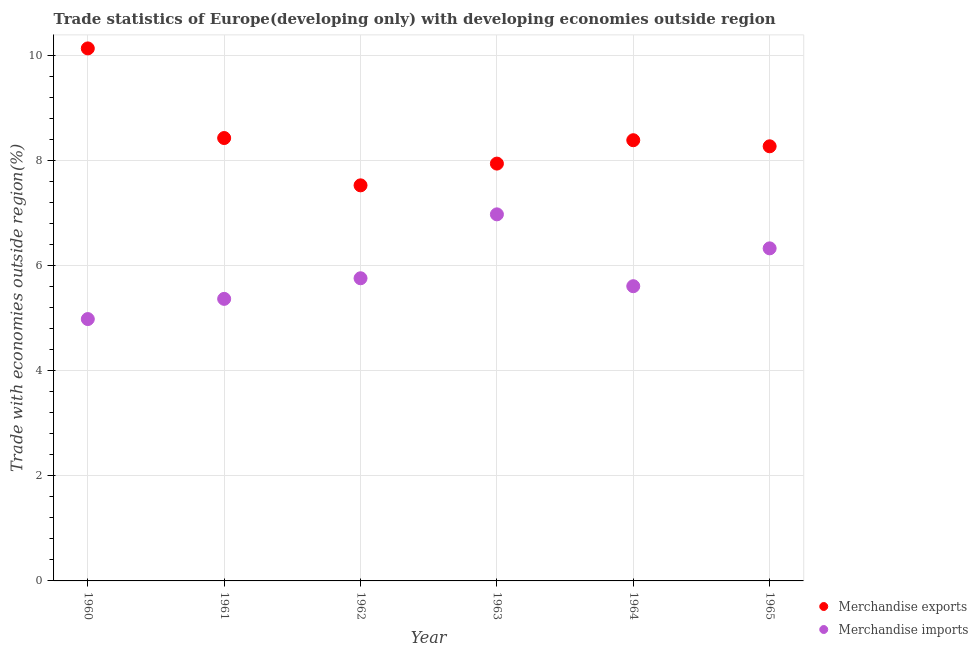What is the merchandise exports in 1960?
Ensure brevity in your answer.  10.13. Across all years, what is the maximum merchandise imports?
Give a very brief answer. 6.97. Across all years, what is the minimum merchandise imports?
Ensure brevity in your answer.  4.98. In which year was the merchandise imports maximum?
Your response must be concise. 1963. What is the total merchandise imports in the graph?
Your response must be concise. 35. What is the difference between the merchandise exports in 1963 and that in 1965?
Provide a short and direct response. -0.33. What is the difference between the merchandise imports in 1965 and the merchandise exports in 1964?
Keep it short and to the point. -2.06. What is the average merchandise exports per year?
Your answer should be compact. 8.44. In the year 1960, what is the difference between the merchandise imports and merchandise exports?
Keep it short and to the point. -5.15. In how many years, is the merchandise exports greater than 2.4 %?
Your answer should be very brief. 6. What is the ratio of the merchandise imports in 1961 to that in 1965?
Your answer should be compact. 0.85. What is the difference between the highest and the second highest merchandise imports?
Offer a terse response. 0.65. What is the difference between the highest and the lowest merchandise imports?
Provide a succinct answer. 1.99. In how many years, is the merchandise exports greater than the average merchandise exports taken over all years?
Offer a very short reply. 1. Does the merchandise imports monotonically increase over the years?
Your response must be concise. No. What is the difference between two consecutive major ticks on the Y-axis?
Ensure brevity in your answer.  2. Where does the legend appear in the graph?
Offer a terse response. Bottom right. How many legend labels are there?
Your answer should be compact. 2. What is the title of the graph?
Provide a succinct answer. Trade statistics of Europe(developing only) with developing economies outside region. Does "Urban" appear as one of the legend labels in the graph?
Give a very brief answer. No. What is the label or title of the Y-axis?
Provide a short and direct response. Trade with economies outside region(%). What is the Trade with economies outside region(%) of Merchandise exports in 1960?
Your answer should be compact. 10.13. What is the Trade with economies outside region(%) of Merchandise imports in 1960?
Your answer should be compact. 4.98. What is the Trade with economies outside region(%) in Merchandise exports in 1961?
Your response must be concise. 8.42. What is the Trade with economies outside region(%) in Merchandise imports in 1961?
Provide a short and direct response. 5.36. What is the Trade with economies outside region(%) of Merchandise exports in 1962?
Provide a succinct answer. 7.52. What is the Trade with economies outside region(%) in Merchandise imports in 1962?
Give a very brief answer. 5.76. What is the Trade with economies outside region(%) of Merchandise exports in 1963?
Your answer should be very brief. 7.94. What is the Trade with economies outside region(%) in Merchandise imports in 1963?
Provide a short and direct response. 6.97. What is the Trade with economies outside region(%) of Merchandise exports in 1964?
Keep it short and to the point. 8.38. What is the Trade with economies outside region(%) in Merchandise imports in 1964?
Offer a very short reply. 5.6. What is the Trade with economies outside region(%) of Merchandise exports in 1965?
Keep it short and to the point. 8.27. What is the Trade with economies outside region(%) of Merchandise imports in 1965?
Provide a short and direct response. 6.32. Across all years, what is the maximum Trade with economies outside region(%) of Merchandise exports?
Ensure brevity in your answer.  10.13. Across all years, what is the maximum Trade with economies outside region(%) of Merchandise imports?
Make the answer very short. 6.97. Across all years, what is the minimum Trade with economies outside region(%) of Merchandise exports?
Offer a very short reply. 7.52. Across all years, what is the minimum Trade with economies outside region(%) in Merchandise imports?
Your response must be concise. 4.98. What is the total Trade with economies outside region(%) in Merchandise exports in the graph?
Ensure brevity in your answer.  50.66. What is the total Trade with economies outside region(%) in Merchandise imports in the graph?
Give a very brief answer. 35. What is the difference between the Trade with economies outside region(%) of Merchandise exports in 1960 and that in 1961?
Keep it short and to the point. 1.7. What is the difference between the Trade with economies outside region(%) of Merchandise imports in 1960 and that in 1961?
Offer a very short reply. -0.38. What is the difference between the Trade with economies outside region(%) in Merchandise exports in 1960 and that in 1962?
Make the answer very short. 2.6. What is the difference between the Trade with economies outside region(%) of Merchandise imports in 1960 and that in 1962?
Your answer should be compact. -0.78. What is the difference between the Trade with economies outside region(%) in Merchandise exports in 1960 and that in 1963?
Your response must be concise. 2.19. What is the difference between the Trade with economies outside region(%) in Merchandise imports in 1960 and that in 1963?
Give a very brief answer. -1.99. What is the difference between the Trade with economies outside region(%) of Merchandise exports in 1960 and that in 1964?
Give a very brief answer. 1.75. What is the difference between the Trade with economies outside region(%) in Merchandise imports in 1960 and that in 1964?
Provide a succinct answer. -0.63. What is the difference between the Trade with economies outside region(%) in Merchandise exports in 1960 and that in 1965?
Ensure brevity in your answer.  1.86. What is the difference between the Trade with economies outside region(%) of Merchandise imports in 1960 and that in 1965?
Ensure brevity in your answer.  -1.34. What is the difference between the Trade with economies outside region(%) in Merchandise exports in 1961 and that in 1962?
Offer a terse response. 0.9. What is the difference between the Trade with economies outside region(%) of Merchandise imports in 1961 and that in 1962?
Offer a terse response. -0.39. What is the difference between the Trade with economies outside region(%) in Merchandise exports in 1961 and that in 1963?
Give a very brief answer. 0.49. What is the difference between the Trade with economies outside region(%) in Merchandise imports in 1961 and that in 1963?
Your response must be concise. -1.61. What is the difference between the Trade with economies outside region(%) in Merchandise exports in 1961 and that in 1964?
Your answer should be very brief. 0.04. What is the difference between the Trade with economies outside region(%) in Merchandise imports in 1961 and that in 1964?
Give a very brief answer. -0.24. What is the difference between the Trade with economies outside region(%) of Merchandise exports in 1961 and that in 1965?
Provide a short and direct response. 0.16. What is the difference between the Trade with economies outside region(%) in Merchandise imports in 1961 and that in 1965?
Make the answer very short. -0.96. What is the difference between the Trade with economies outside region(%) in Merchandise exports in 1962 and that in 1963?
Keep it short and to the point. -0.41. What is the difference between the Trade with economies outside region(%) of Merchandise imports in 1962 and that in 1963?
Offer a very short reply. -1.22. What is the difference between the Trade with economies outside region(%) of Merchandise exports in 1962 and that in 1964?
Provide a short and direct response. -0.86. What is the difference between the Trade with economies outside region(%) in Merchandise imports in 1962 and that in 1964?
Provide a short and direct response. 0.15. What is the difference between the Trade with economies outside region(%) of Merchandise exports in 1962 and that in 1965?
Provide a short and direct response. -0.74. What is the difference between the Trade with economies outside region(%) of Merchandise imports in 1962 and that in 1965?
Offer a terse response. -0.57. What is the difference between the Trade with economies outside region(%) of Merchandise exports in 1963 and that in 1964?
Keep it short and to the point. -0.44. What is the difference between the Trade with economies outside region(%) in Merchandise imports in 1963 and that in 1964?
Give a very brief answer. 1.37. What is the difference between the Trade with economies outside region(%) of Merchandise exports in 1963 and that in 1965?
Make the answer very short. -0.33. What is the difference between the Trade with economies outside region(%) of Merchandise imports in 1963 and that in 1965?
Offer a very short reply. 0.65. What is the difference between the Trade with economies outside region(%) of Merchandise exports in 1964 and that in 1965?
Make the answer very short. 0.12. What is the difference between the Trade with economies outside region(%) in Merchandise imports in 1964 and that in 1965?
Ensure brevity in your answer.  -0.72. What is the difference between the Trade with economies outside region(%) in Merchandise exports in 1960 and the Trade with economies outside region(%) in Merchandise imports in 1961?
Offer a terse response. 4.76. What is the difference between the Trade with economies outside region(%) of Merchandise exports in 1960 and the Trade with economies outside region(%) of Merchandise imports in 1962?
Offer a very short reply. 4.37. What is the difference between the Trade with economies outside region(%) in Merchandise exports in 1960 and the Trade with economies outside region(%) in Merchandise imports in 1963?
Your response must be concise. 3.16. What is the difference between the Trade with economies outside region(%) in Merchandise exports in 1960 and the Trade with economies outside region(%) in Merchandise imports in 1964?
Ensure brevity in your answer.  4.52. What is the difference between the Trade with economies outside region(%) of Merchandise exports in 1960 and the Trade with economies outside region(%) of Merchandise imports in 1965?
Keep it short and to the point. 3.8. What is the difference between the Trade with economies outside region(%) of Merchandise exports in 1961 and the Trade with economies outside region(%) of Merchandise imports in 1962?
Your response must be concise. 2.67. What is the difference between the Trade with economies outside region(%) of Merchandise exports in 1961 and the Trade with economies outside region(%) of Merchandise imports in 1963?
Offer a very short reply. 1.45. What is the difference between the Trade with economies outside region(%) in Merchandise exports in 1961 and the Trade with economies outside region(%) in Merchandise imports in 1964?
Your response must be concise. 2.82. What is the difference between the Trade with economies outside region(%) of Merchandise exports in 1961 and the Trade with economies outside region(%) of Merchandise imports in 1965?
Keep it short and to the point. 2.1. What is the difference between the Trade with economies outside region(%) in Merchandise exports in 1962 and the Trade with economies outside region(%) in Merchandise imports in 1963?
Make the answer very short. 0.55. What is the difference between the Trade with economies outside region(%) of Merchandise exports in 1962 and the Trade with economies outside region(%) of Merchandise imports in 1964?
Your answer should be very brief. 1.92. What is the difference between the Trade with economies outside region(%) of Merchandise exports in 1962 and the Trade with economies outside region(%) of Merchandise imports in 1965?
Ensure brevity in your answer.  1.2. What is the difference between the Trade with economies outside region(%) of Merchandise exports in 1963 and the Trade with economies outside region(%) of Merchandise imports in 1964?
Give a very brief answer. 2.33. What is the difference between the Trade with economies outside region(%) in Merchandise exports in 1963 and the Trade with economies outside region(%) in Merchandise imports in 1965?
Keep it short and to the point. 1.61. What is the difference between the Trade with economies outside region(%) in Merchandise exports in 1964 and the Trade with economies outside region(%) in Merchandise imports in 1965?
Keep it short and to the point. 2.06. What is the average Trade with economies outside region(%) of Merchandise exports per year?
Give a very brief answer. 8.44. What is the average Trade with economies outside region(%) of Merchandise imports per year?
Your answer should be compact. 5.83. In the year 1960, what is the difference between the Trade with economies outside region(%) of Merchandise exports and Trade with economies outside region(%) of Merchandise imports?
Keep it short and to the point. 5.15. In the year 1961, what is the difference between the Trade with economies outside region(%) in Merchandise exports and Trade with economies outside region(%) in Merchandise imports?
Keep it short and to the point. 3.06. In the year 1962, what is the difference between the Trade with economies outside region(%) in Merchandise exports and Trade with economies outside region(%) in Merchandise imports?
Provide a short and direct response. 1.77. In the year 1963, what is the difference between the Trade with economies outside region(%) of Merchandise exports and Trade with economies outside region(%) of Merchandise imports?
Keep it short and to the point. 0.97. In the year 1964, what is the difference between the Trade with economies outside region(%) in Merchandise exports and Trade with economies outside region(%) in Merchandise imports?
Your answer should be compact. 2.78. In the year 1965, what is the difference between the Trade with economies outside region(%) in Merchandise exports and Trade with economies outside region(%) in Merchandise imports?
Your answer should be compact. 1.94. What is the ratio of the Trade with economies outside region(%) of Merchandise exports in 1960 to that in 1961?
Give a very brief answer. 1.2. What is the ratio of the Trade with economies outside region(%) in Merchandise imports in 1960 to that in 1961?
Provide a succinct answer. 0.93. What is the ratio of the Trade with economies outside region(%) in Merchandise exports in 1960 to that in 1962?
Your response must be concise. 1.35. What is the ratio of the Trade with economies outside region(%) in Merchandise imports in 1960 to that in 1962?
Your response must be concise. 0.87. What is the ratio of the Trade with economies outside region(%) of Merchandise exports in 1960 to that in 1963?
Your answer should be compact. 1.28. What is the ratio of the Trade with economies outside region(%) of Merchandise exports in 1960 to that in 1964?
Offer a terse response. 1.21. What is the ratio of the Trade with economies outside region(%) of Merchandise imports in 1960 to that in 1964?
Your answer should be compact. 0.89. What is the ratio of the Trade with economies outside region(%) in Merchandise exports in 1960 to that in 1965?
Your answer should be compact. 1.23. What is the ratio of the Trade with economies outside region(%) of Merchandise imports in 1960 to that in 1965?
Ensure brevity in your answer.  0.79. What is the ratio of the Trade with economies outside region(%) of Merchandise exports in 1961 to that in 1962?
Provide a short and direct response. 1.12. What is the ratio of the Trade with economies outside region(%) of Merchandise imports in 1961 to that in 1962?
Give a very brief answer. 0.93. What is the ratio of the Trade with economies outside region(%) of Merchandise exports in 1961 to that in 1963?
Your answer should be very brief. 1.06. What is the ratio of the Trade with economies outside region(%) of Merchandise imports in 1961 to that in 1963?
Give a very brief answer. 0.77. What is the ratio of the Trade with economies outside region(%) in Merchandise exports in 1961 to that in 1964?
Your answer should be very brief. 1. What is the ratio of the Trade with economies outside region(%) of Merchandise imports in 1961 to that in 1964?
Offer a very short reply. 0.96. What is the ratio of the Trade with economies outside region(%) in Merchandise imports in 1961 to that in 1965?
Your answer should be compact. 0.85. What is the ratio of the Trade with economies outside region(%) of Merchandise exports in 1962 to that in 1963?
Make the answer very short. 0.95. What is the ratio of the Trade with economies outside region(%) in Merchandise imports in 1962 to that in 1963?
Provide a succinct answer. 0.83. What is the ratio of the Trade with economies outside region(%) of Merchandise exports in 1962 to that in 1964?
Provide a short and direct response. 0.9. What is the ratio of the Trade with economies outside region(%) in Merchandise imports in 1962 to that in 1964?
Keep it short and to the point. 1.03. What is the ratio of the Trade with economies outside region(%) of Merchandise exports in 1962 to that in 1965?
Your response must be concise. 0.91. What is the ratio of the Trade with economies outside region(%) of Merchandise imports in 1962 to that in 1965?
Give a very brief answer. 0.91. What is the ratio of the Trade with economies outside region(%) of Merchandise exports in 1963 to that in 1964?
Your answer should be compact. 0.95. What is the ratio of the Trade with economies outside region(%) of Merchandise imports in 1963 to that in 1964?
Ensure brevity in your answer.  1.24. What is the ratio of the Trade with economies outside region(%) in Merchandise exports in 1963 to that in 1965?
Ensure brevity in your answer.  0.96. What is the ratio of the Trade with economies outside region(%) of Merchandise imports in 1963 to that in 1965?
Ensure brevity in your answer.  1.1. What is the ratio of the Trade with economies outside region(%) of Merchandise exports in 1964 to that in 1965?
Your answer should be compact. 1.01. What is the ratio of the Trade with economies outside region(%) of Merchandise imports in 1964 to that in 1965?
Offer a terse response. 0.89. What is the difference between the highest and the second highest Trade with economies outside region(%) in Merchandise exports?
Keep it short and to the point. 1.7. What is the difference between the highest and the second highest Trade with economies outside region(%) in Merchandise imports?
Provide a short and direct response. 0.65. What is the difference between the highest and the lowest Trade with economies outside region(%) in Merchandise exports?
Keep it short and to the point. 2.6. What is the difference between the highest and the lowest Trade with economies outside region(%) in Merchandise imports?
Ensure brevity in your answer.  1.99. 